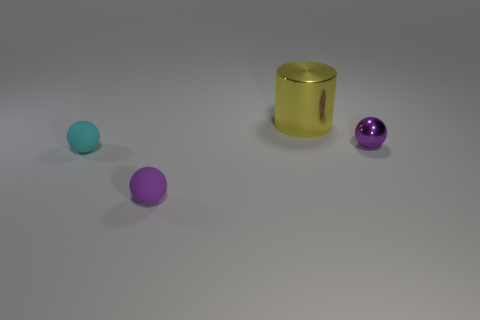Add 2 large gray metallic spheres. How many objects exist? 6 Subtract all matte balls. How many balls are left? 1 Subtract all cyan spheres. How many spheres are left? 2 Subtract 2 spheres. How many spheres are left? 1 Subtract all blue cylinders. How many purple spheres are left? 2 Subtract all balls. How many objects are left? 1 Subtract all green cylinders. Subtract all blue blocks. How many cylinders are left? 1 Subtract all tiny green rubber spheres. Subtract all tiny purple things. How many objects are left? 2 Add 4 big yellow cylinders. How many big yellow cylinders are left? 5 Add 1 big blue shiny objects. How many big blue shiny objects exist? 1 